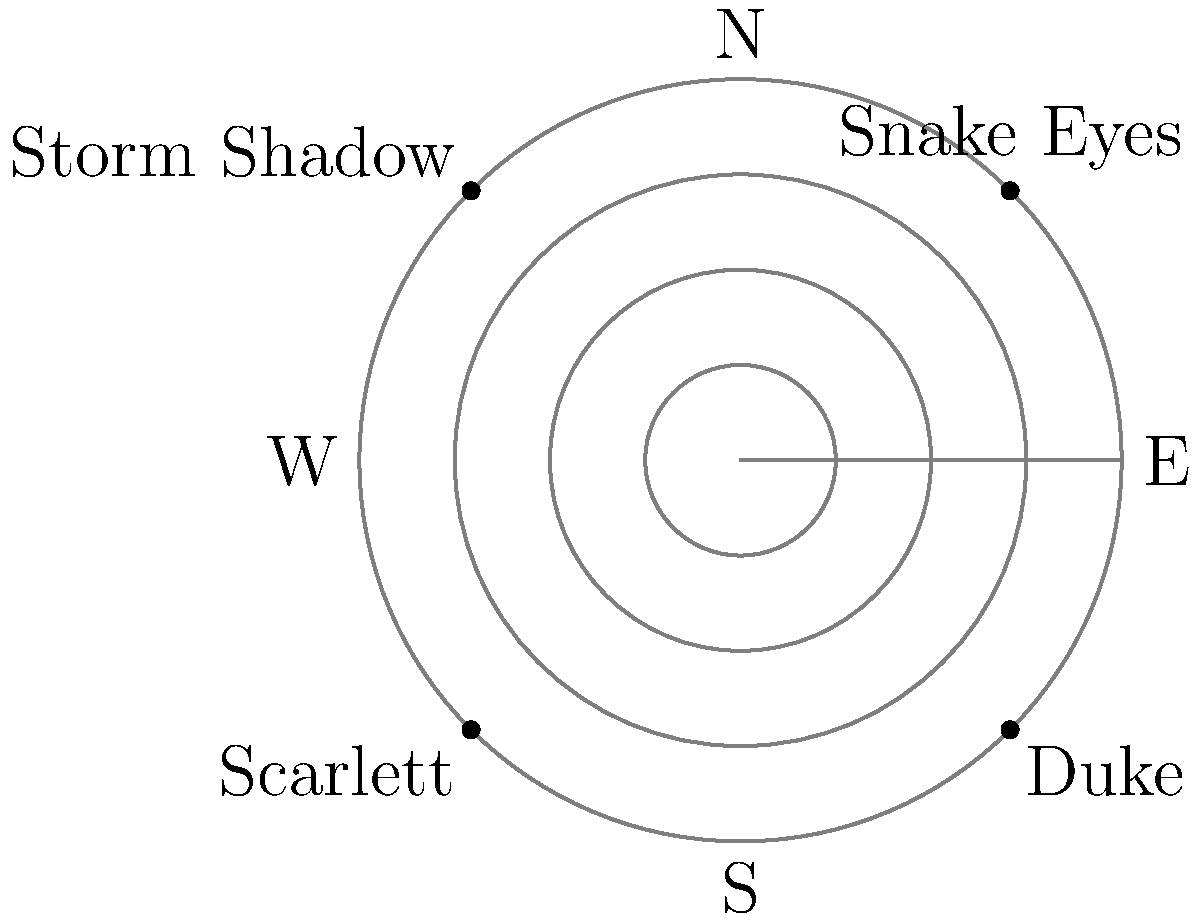In a G.I. Joe battle scene, four characters are positioned on a polar grid as shown. If Snake Eyes decides to move directly towards Storm Shadow, what will be his new coordinates $(r, \theta)$ when he reaches the midpoint between their current positions? To solve this problem, let's follow these steps:

1. Identify the current positions:
   Snake Eyes: $(5, 45°)$
   Storm Shadow: $(5, 135°)$

2. Calculate the midpoint:
   a) For the radius $r$:
      Both characters are at $r = 5$, so the midpoint $r$ remains 5.
   
   b) For the angle $\theta$:
      Snake Eyes is at $45°$ and Storm Shadow is at $135°$.
      Midpoint angle = $(45° + 135°) / 2 = 180° / 2 = 90°$

3. Convert to polar coordinates:
   The midpoint position is $(5, 90°)$

Therefore, Snake Eyes' new coordinates when he reaches the midpoint between his current position and Storm Shadow's position will be $(5, 90°)$.
Answer: $(5, 90°)$ 